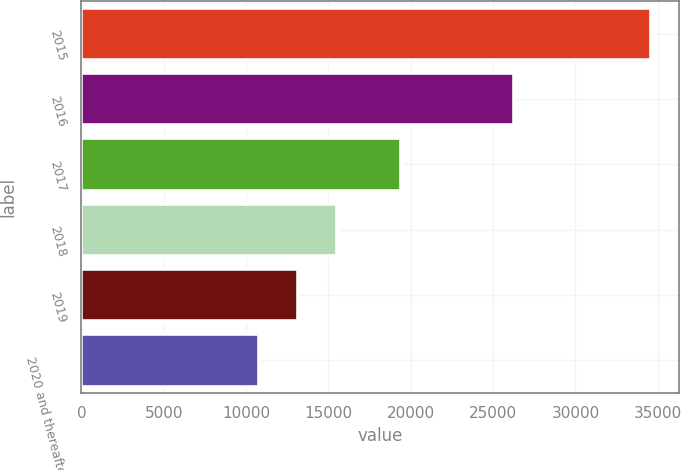<chart> <loc_0><loc_0><loc_500><loc_500><bar_chart><fcel>2015<fcel>2016<fcel>2017<fcel>2018<fcel>2019<fcel>2020 and thereafter<nl><fcel>34583<fcel>26246<fcel>19418<fcel>15520.6<fcel>13137.8<fcel>10755<nl></chart> 